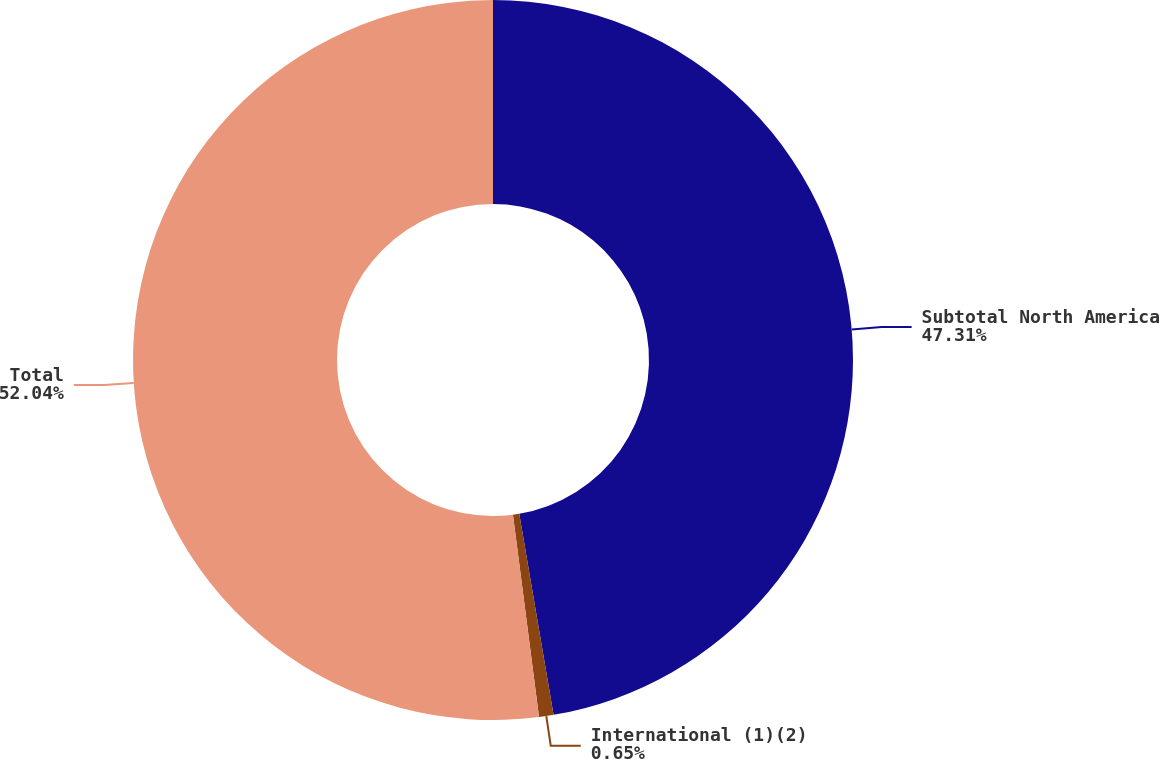<chart> <loc_0><loc_0><loc_500><loc_500><pie_chart><fcel>Subtotal North America<fcel>International (1)(2)<fcel>Total<nl><fcel>47.31%<fcel>0.65%<fcel>52.04%<nl></chart> 